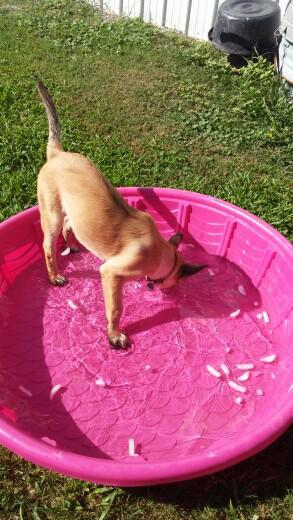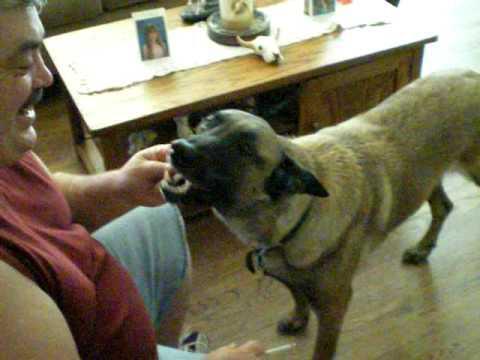The first image is the image on the left, the second image is the image on the right. Considering the images on both sides, is "At least one leash is visible in both images." valid? Answer yes or no. No. The first image is the image on the left, the second image is the image on the right. For the images displayed, is the sentence "One german shepherd is standing and the other german shepherd is posed with its front paws extended; at least one dog wears a collar and leash but no dog wears a muzzle." factually correct? Answer yes or no. No. 